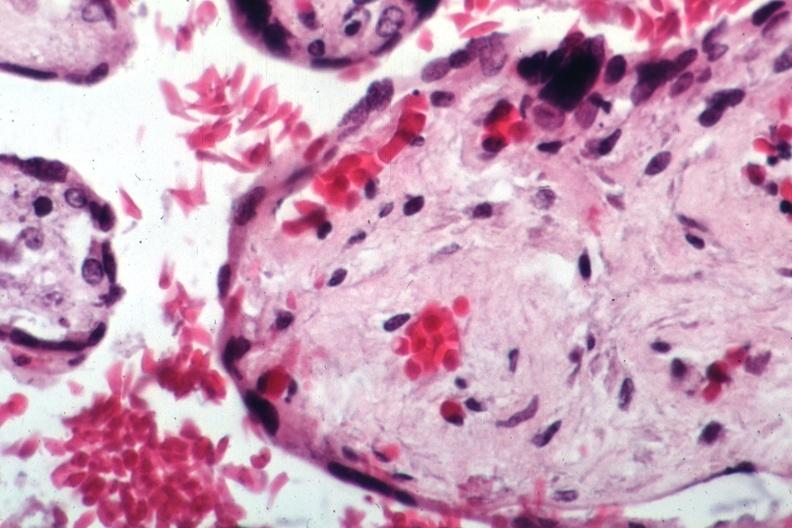what is present?
Answer the question using a single word or phrase. Female reproductive 